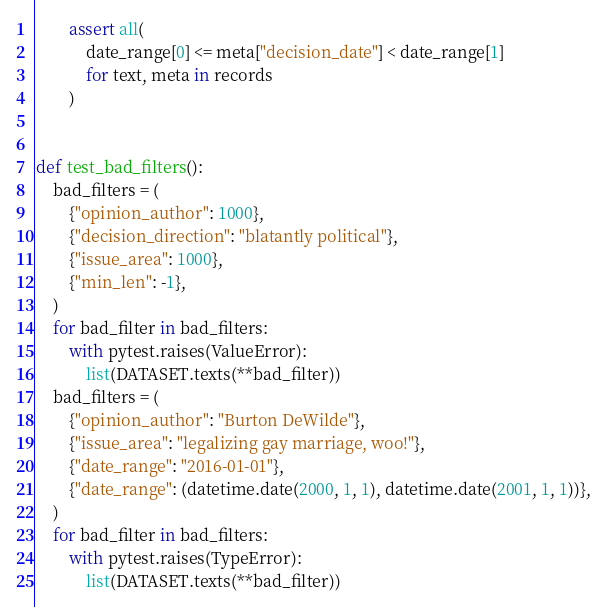<code> <loc_0><loc_0><loc_500><loc_500><_Python_>        assert all(
            date_range[0] <= meta["decision_date"] < date_range[1]
            for text, meta in records
        )


def test_bad_filters():
    bad_filters = (
        {"opinion_author": 1000},
        {"decision_direction": "blatantly political"},
        {"issue_area": 1000},
        {"min_len": -1},
    )
    for bad_filter in bad_filters:
        with pytest.raises(ValueError):
            list(DATASET.texts(**bad_filter))
    bad_filters = (
        {"opinion_author": "Burton DeWilde"},
        {"issue_area": "legalizing gay marriage, woo!"},
        {"date_range": "2016-01-01"},
        {"date_range": (datetime.date(2000, 1, 1), datetime.date(2001, 1, 1))},
    )
    for bad_filter in bad_filters:
        with pytest.raises(TypeError):
            list(DATASET.texts(**bad_filter))
</code> 